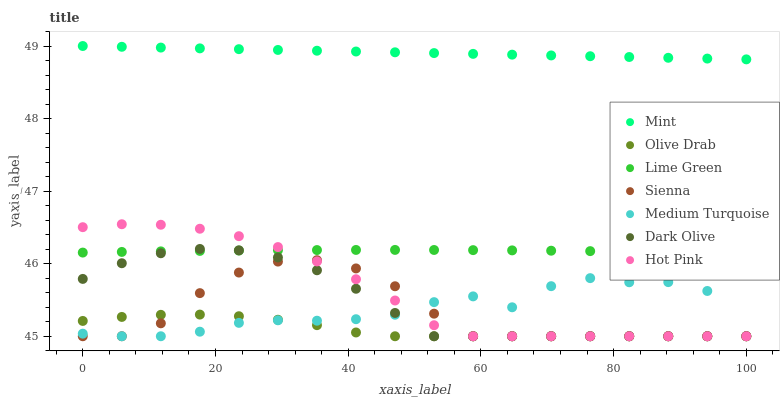Does Olive Drab have the minimum area under the curve?
Answer yes or no. Yes. Does Mint have the maximum area under the curve?
Answer yes or no. Yes. Does Dark Olive have the minimum area under the curve?
Answer yes or no. No. Does Dark Olive have the maximum area under the curve?
Answer yes or no. No. Is Mint the smoothest?
Answer yes or no. Yes. Is Medium Turquoise the roughest?
Answer yes or no. Yes. Is Dark Olive the smoothest?
Answer yes or no. No. Is Dark Olive the roughest?
Answer yes or no. No. Does Hot Pink have the lowest value?
Answer yes or no. Yes. Does Mint have the lowest value?
Answer yes or no. No. Does Mint have the highest value?
Answer yes or no. Yes. Does Dark Olive have the highest value?
Answer yes or no. No. Is Olive Drab less than Mint?
Answer yes or no. Yes. Is Mint greater than Hot Pink?
Answer yes or no. Yes. Does Sienna intersect Dark Olive?
Answer yes or no. Yes. Is Sienna less than Dark Olive?
Answer yes or no. No. Is Sienna greater than Dark Olive?
Answer yes or no. No. Does Olive Drab intersect Mint?
Answer yes or no. No. 